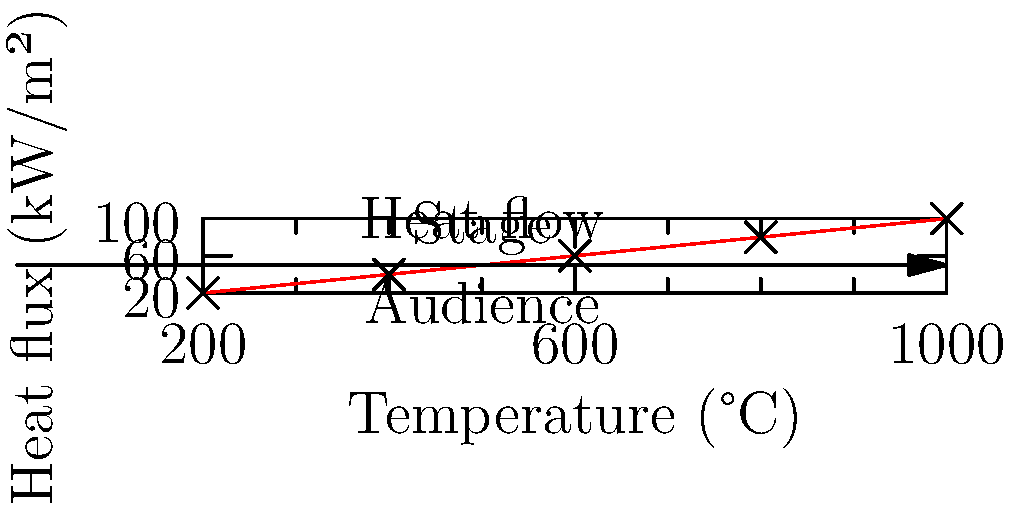Based on the heat flow diagram for pyrotechnic effects in a concert, what is the approximate heat flux reaching the audience when the pyrotechnic temperature is 600°C? To determine the heat flux reaching the audience at a pyrotechnic temperature of 600°C, we need to follow these steps:

1. Observe the graph, which shows the relationship between temperature (x-axis) and heat flux (y-axis).
2. Locate the point on the x-axis corresponding to 600°C.
3. Find the corresponding y-value (heat flux) for this temperature.
4. From the graph, we can see that at 600°C, the heat flux is approximately 60 kW/m².
5. This value represents the heat flux reaching the stage area.
6. Notice the arrow indicating heat flow from the stage to the audience.
7. The audience receives only a fraction of this heat flux due to distance and dispersion.
8. Based on the graph, we can estimate that the audience receives about 1/3 of the stage heat flux.

Therefore, the approximate heat flux reaching the audience at 600°C is:

$$ \text{Audience Heat Flux} \approx \frac{1}{3} \times 60 \text{ kW/m²} \approx 20 \text{ kW/m²} $$
Answer: 20 kW/m² 